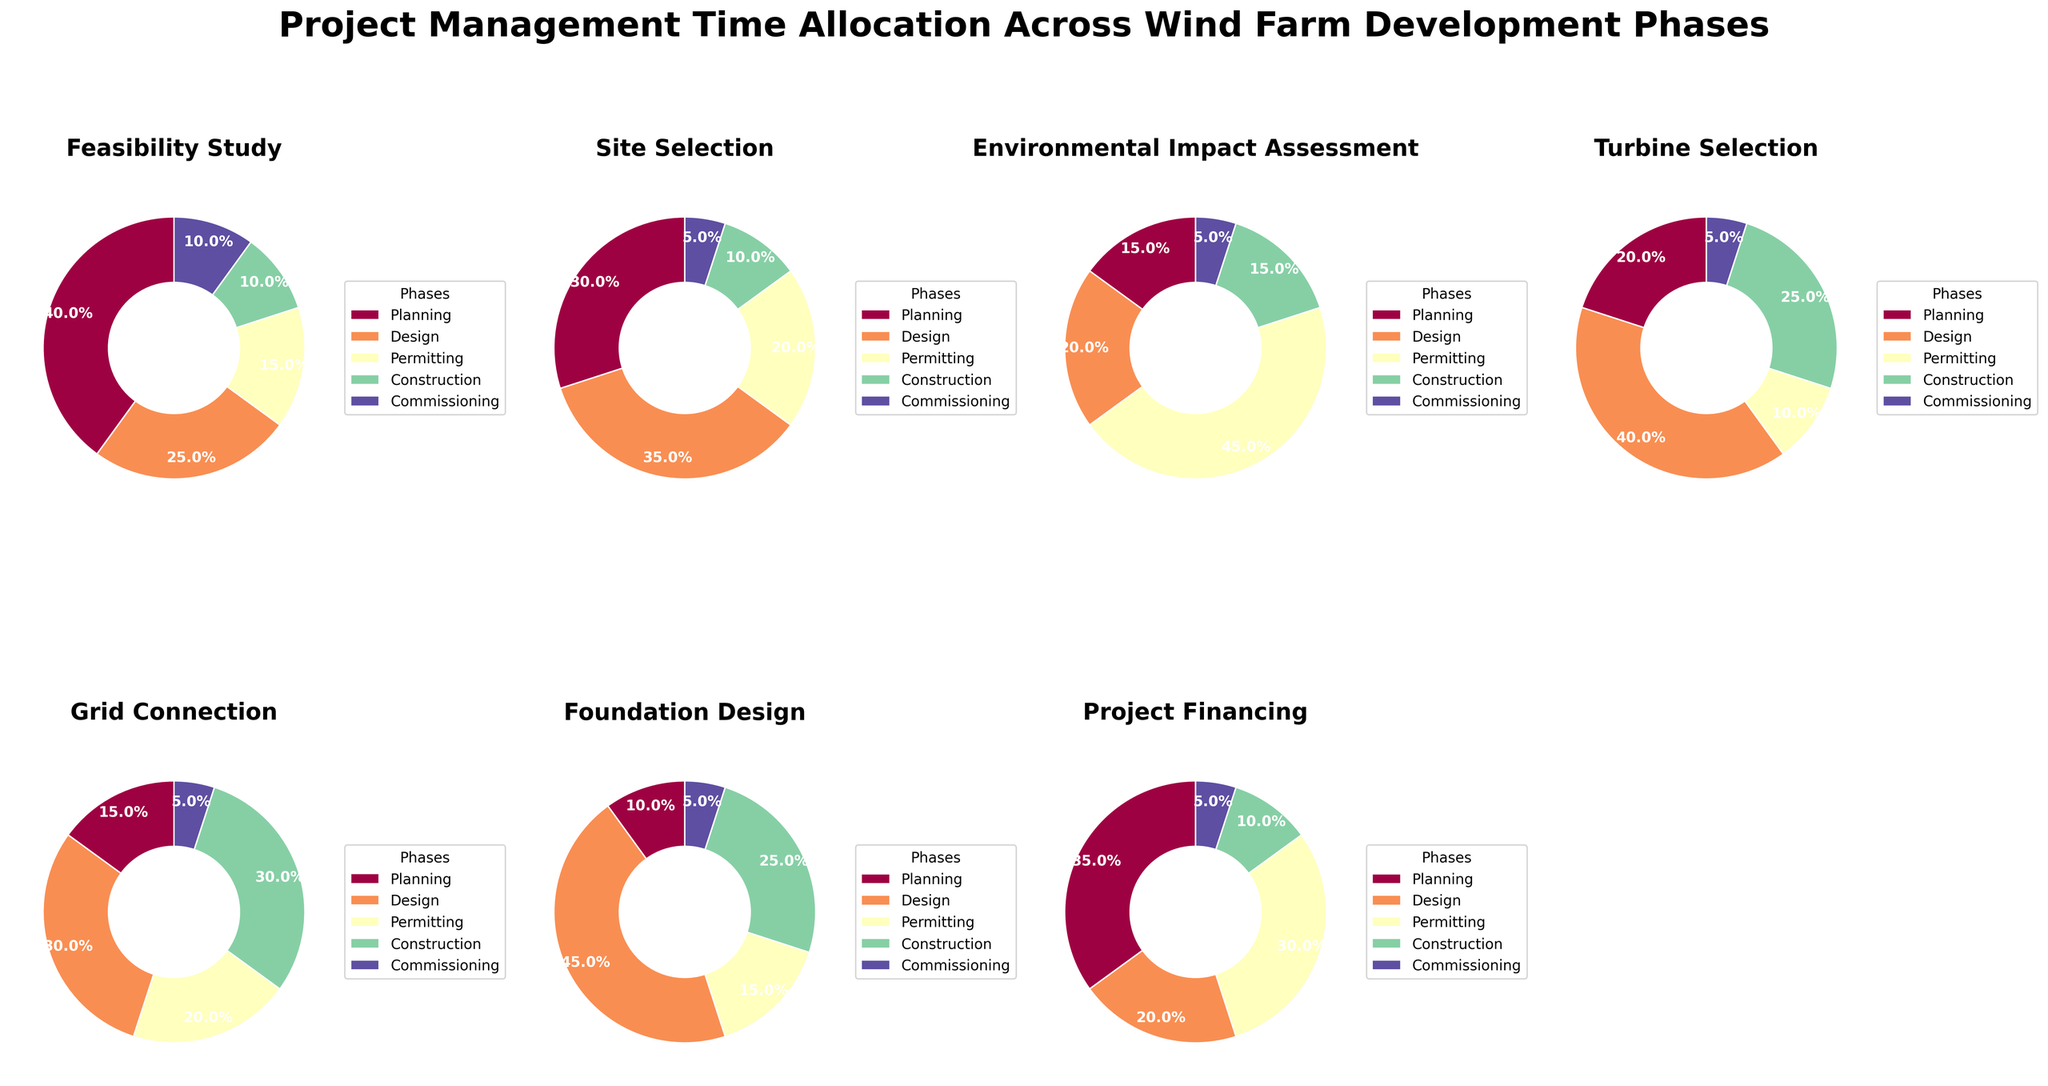What percentage of time is allocated to Planning during the Feasibility Study phase? Look at the pie chart titled "Feasibility Study" and check the segment corresponding to Planning. The label shows the percentage.
Answer: 40% Which phase dedicates the highest percentage of time to Permitting? Compare the percentages for Permitting across all phases. The "Environmental Impact Assessment" phase shows the highest value at 45%.
Answer: Environmental Impact Assessment How does the time allocation for Construction compare between the Turbine Selection and Foundation Design phases? Turbine Selection allocates 25% of time to Construction, while Foundation Design allocates the same at 25%.
Answer: Same Which phase has the least time allocation for Commissioning? Look at the percentages for Commissioning across all phases. Both Site Selection and Project Financing allocate 5%, which is the least.
Answer: Site Selection, Project Financing What is the combined percentage of time allocated to Planning and Design during the Feasibility Study phase? Add the percentage values for Planning (40%) and Design (25%) during the Feasibility Study phase. 40% + 25% = 65%
Answer: 65% How much more time does the Foundation Design phase allocate to Design compared to Planning? Subtract the percentage allocated to Planning from Design in the Foundation Design phase. Design (45%) - Planning (10%) = 35%
Answer: 35% Which phases have an equal percentage allocation for any two categories? Examine each phase and find any two categories with equal percentages. For instance, in the Turbine Selection phase, both Construction and Planning allocate 25%.
Answer: Turbine Selection Which phase shows the most balanced time allocation (smallest range between highest and lowest percentages) and what is the range? For each phase, calculate the range by subtracting the smallest percentage from the largest. The range for Site Selection (35% - 5% = 30%) and Project Financing (35%-5%=30%) is the smallest.
Answer: Site Selection, Project Financing; 30% Across all phases, which category gets the least amount of time in general? Assess all pie charts for the lowest frequent percentage category. Commissioning frequently gets the least time allocations across multiple phases, such as 5% in several phases.
Answer: Commissioning 